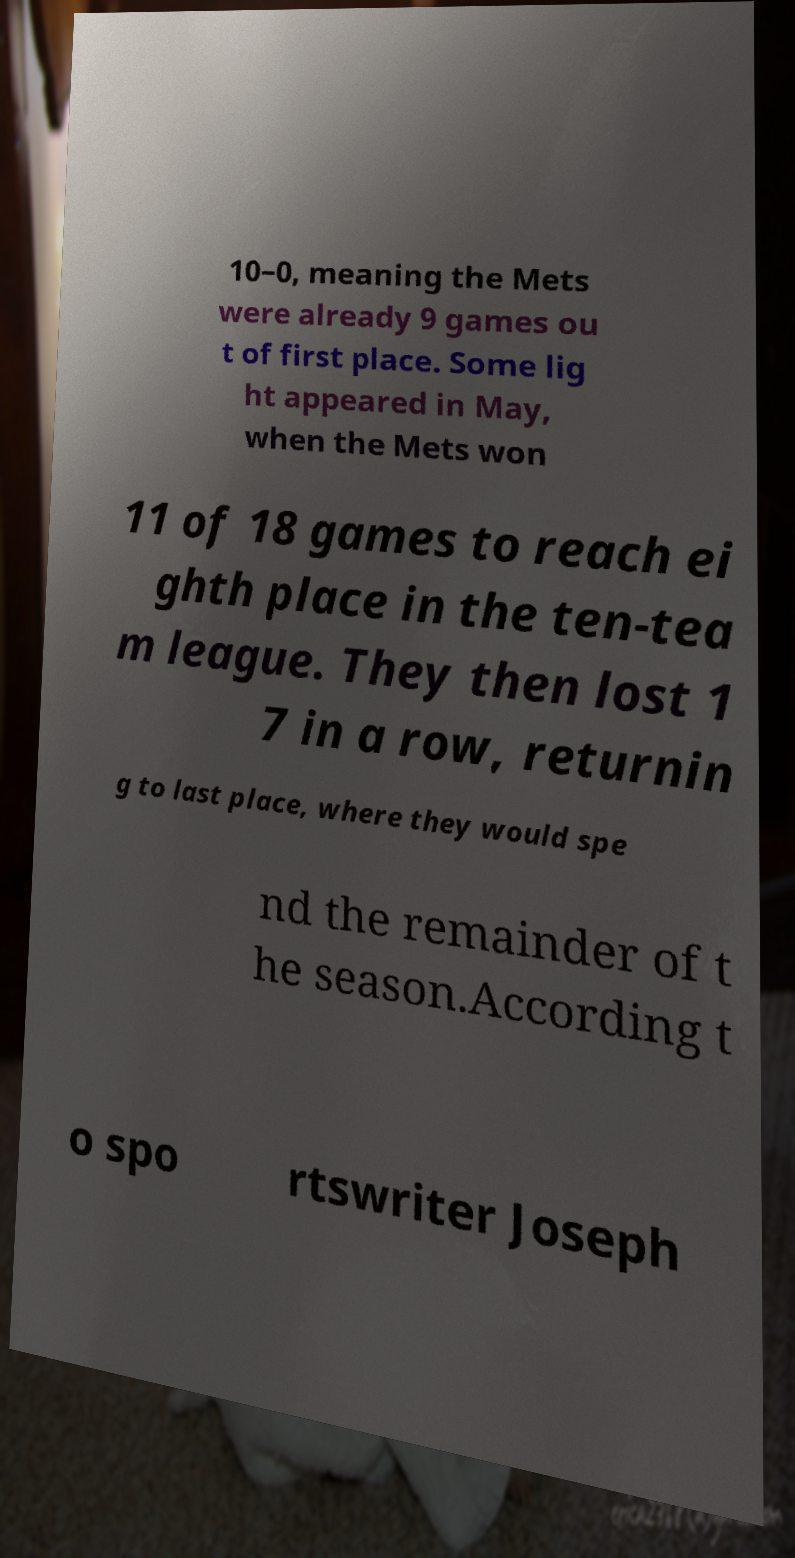Can you accurately transcribe the text from the provided image for me? 10–0, meaning the Mets were already 9 games ou t of first place. Some lig ht appeared in May, when the Mets won 11 of 18 games to reach ei ghth place in the ten-tea m league. They then lost 1 7 in a row, returnin g to last place, where they would spe nd the remainder of t he season.According t o spo rtswriter Joseph 